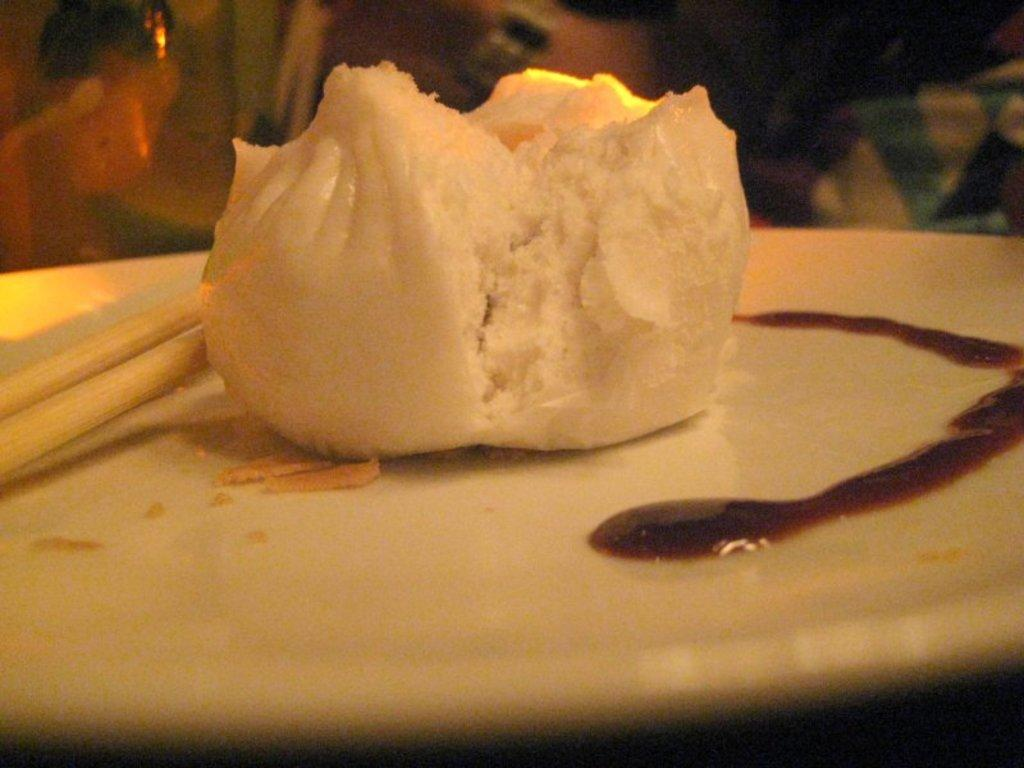What type of food is shown in the image? There is a momo in the image. What utensils are used to eat the food in the image? Chopsticks are visible in the image. What accompanies the momo and chopsticks on the plate? There is sauce in the image. How are the momo, chopsticks, and sauce arranged in the image? They are placed on a plate. What type of power does the man in the image possess? There is no man present in the image, so it is not possible to determine what type of power he might possess. 